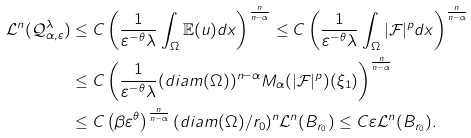<formula> <loc_0><loc_0><loc_500><loc_500>\mathcal { L } ^ { n } ( \mathcal { Q } ^ { \lambda } _ { \alpha , \varepsilon } ) & \leq C \left ( \frac { 1 } { \varepsilon ^ { - \theta } \lambda } \int _ { \Omega } { \mathbb { E } ( u ) d x } \right ) ^ { \frac { n } { n - \alpha } } \leq C \left ( \frac { 1 } { \varepsilon ^ { - \theta } \lambda } \int _ { \Omega } { | \mathcal { F } | ^ { p } d x } \right ) ^ { \frac { n } { n - \alpha } } \\ & \leq C \left ( \frac { 1 } { \varepsilon ^ { - \theta } \lambda } ( d i a m ( \Omega ) ) ^ { n - \alpha } M _ { \alpha } ( | \mathcal { F } | ^ { p } ) ( \xi _ { 1 } ) \right ) ^ { \frac { n } { n - \alpha } } \\ & \leq C \left ( \beta \varepsilon ^ { \theta } \right ) ^ { \frac { n } { n - \alpha } } ( d i a m ( \Omega ) / r _ { 0 } ) ^ { n } \mathcal { L } ^ { n } ( B _ { r _ { 0 } } ) \leq C \varepsilon \mathcal { L } ^ { n } ( B _ { r _ { 0 } } ) .</formula> 